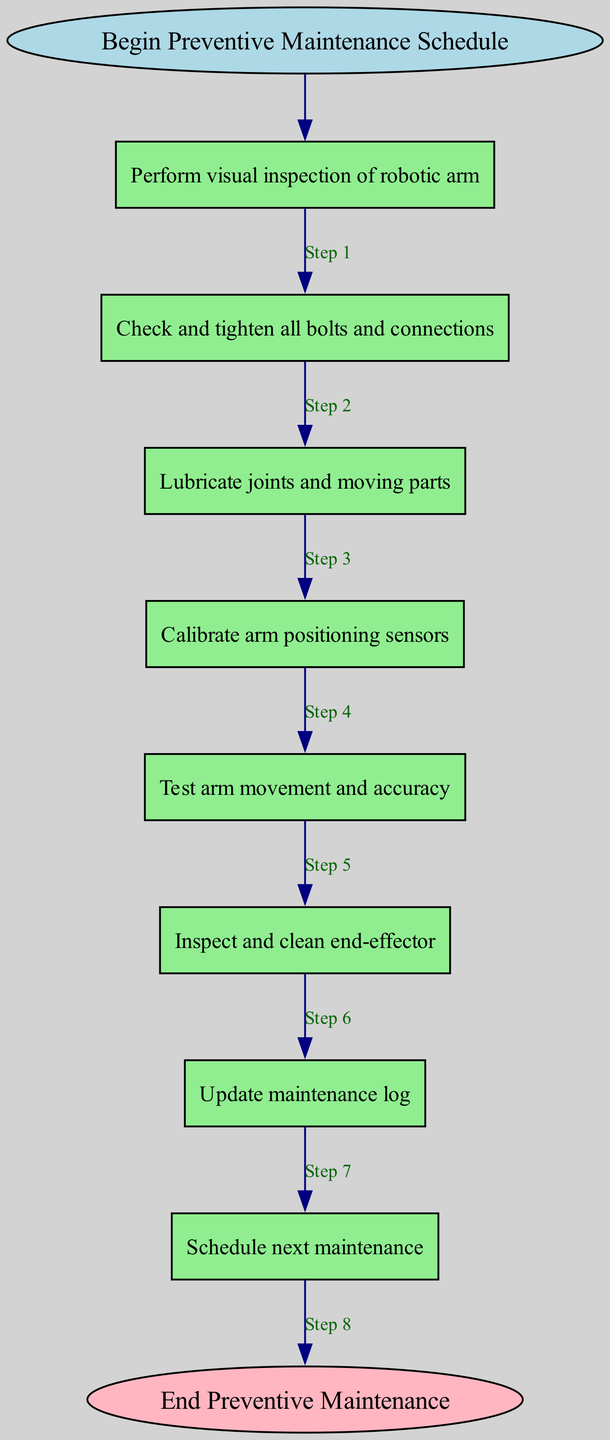What is the first step in the preventive maintenance schedule? The first step is detailed in the first node, which states, "Perform visual inspection of robotic arm." This indicates the initial task that needs to be completed before moving to subsequent steps.
Answer: Perform visual inspection of robotic arm How many total steps are there in the preventive maintenance schedule? By counting the individual steps listed in the diagram, we find there are 8 steps in total that guide the preventive maintenance process.
Answer: 8 What action follows "Lubricate joints and moving parts"? To determine this, we look at the diagram's flow from the "Lubricate joints and moving parts" node, which points to the next step, "Calibrate arm positioning sensors." This indicates the sequential order of tasks.
Answer: Calibrate arm positioning sensors What is the final step in the preventive maintenance schedule? The final step is identified at the end of the diagram flow, which is indicated as "Schedule next maintenance." This step signifies the conclusion of the current maintenance routine.
Answer: Schedule next maintenance Which step requires inspecting and cleaning a specific component? The step that involves inspecting and cleaning is specifically stated as "Inspect and clean end-effector," which outlines the need to maintain the end-effector component of the robotic arm.
Answer: Inspect and clean end-effector How many visual inspections are performed in the preventive maintenance schedule? The schedule indicates only one specific visual inspection in the first step, as there are no other occurrences of this action mentioned in the following steps.
Answer: 1 In the order of steps, what is the third activity after the initial inspection? After performing the visual inspection and checking and tightening bolts and connections, the third activity involves "Lubricate joints and moving parts," which follows directly in the schedule.
Answer: Lubricate joints and moving parts Which step comes before updating the maintenance log? The step preceding "Update maintenance log" is "Inspect and clean end-effector," demonstrating that cleaning and checking the end-effector is necessary before logging the maintenance performed.
Answer: Inspect and clean end-effector 